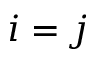<formula> <loc_0><loc_0><loc_500><loc_500>i = j</formula> 